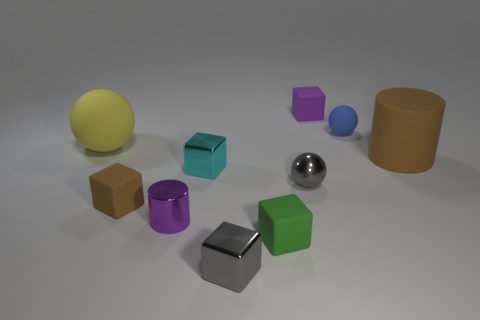Subtract all cylinders. How many objects are left? 8 Subtract all yellow spheres. Subtract all small brown rubber objects. How many objects are left? 8 Add 6 tiny cyan objects. How many tiny cyan objects are left? 7 Add 4 large brown objects. How many large brown objects exist? 5 Subtract 0 blue blocks. How many objects are left? 10 